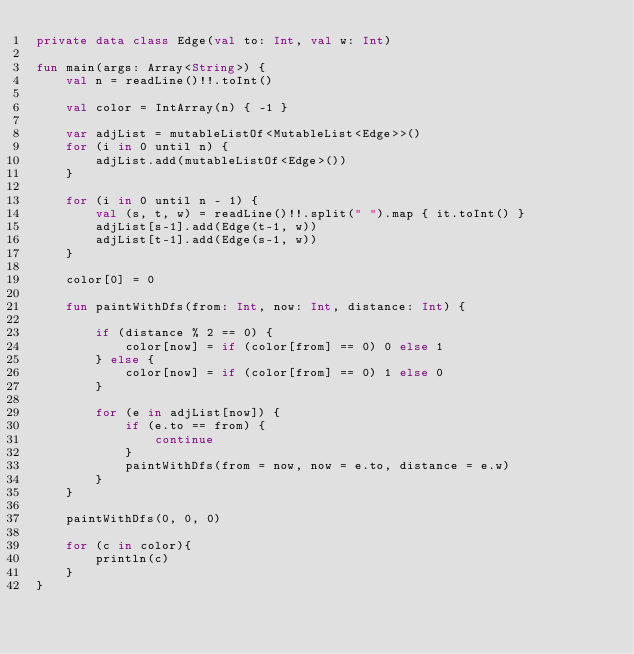<code> <loc_0><loc_0><loc_500><loc_500><_Kotlin_>private data class Edge(val to: Int, val w: Int)

fun main(args: Array<String>) {
    val n = readLine()!!.toInt()

    val color = IntArray(n) { -1 }

    var adjList = mutableListOf<MutableList<Edge>>()
    for (i in 0 until n) {
        adjList.add(mutableListOf<Edge>())
    }

    for (i in 0 until n - 1) {
        val (s, t, w) = readLine()!!.split(" ").map { it.toInt() }
        adjList[s-1].add(Edge(t-1, w))
        adjList[t-1].add(Edge(s-1, w))
    }

    color[0] = 0

    fun paintWithDfs(from: Int, now: Int, distance: Int) {

        if (distance % 2 == 0) {
            color[now] = if (color[from] == 0) 0 else 1
        } else {
            color[now] = if (color[from] == 0) 1 else 0
        }

        for (e in adjList[now]) {
            if (e.to == from) {
                continue
            }
            paintWithDfs(from = now, now = e.to, distance = e.w)
        }
    }

    paintWithDfs(0, 0, 0)

    for (c in color){
        println(c)
    }
}</code> 